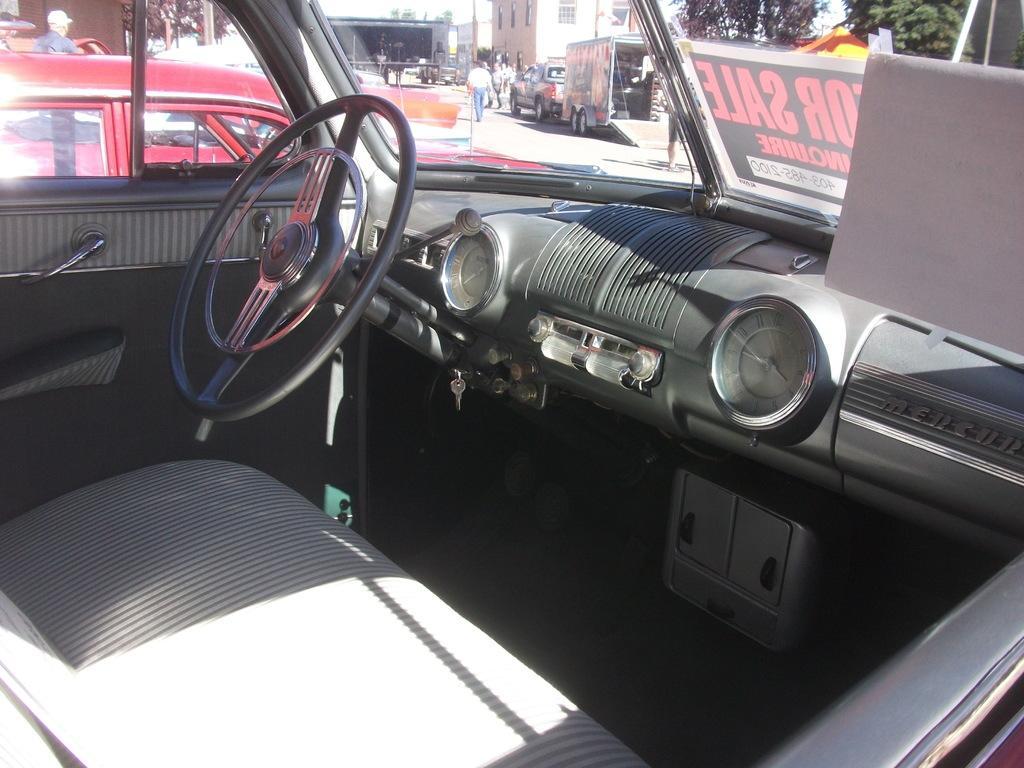How would you summarize this image in a sentence or two? In this image we can see the interior of the car and there is a poster with some text on it, through the window we can see, there are many vehicles, buildings, trees and people. 